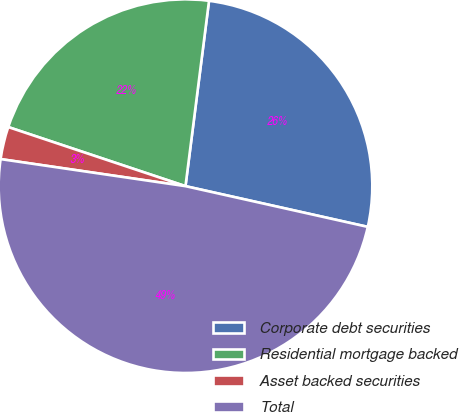<chart> <loc_0><loc_0><loc_500><loc_500><pie_chart><fcel>Corporate debt securities<fcel>Residential mortgage backed<fcel>Asset backed securities<fcel>Total<nl><fcel>26.49%<fcel>21.89%<fcel>2.81%<fcel>48.82%<nl></chart> 